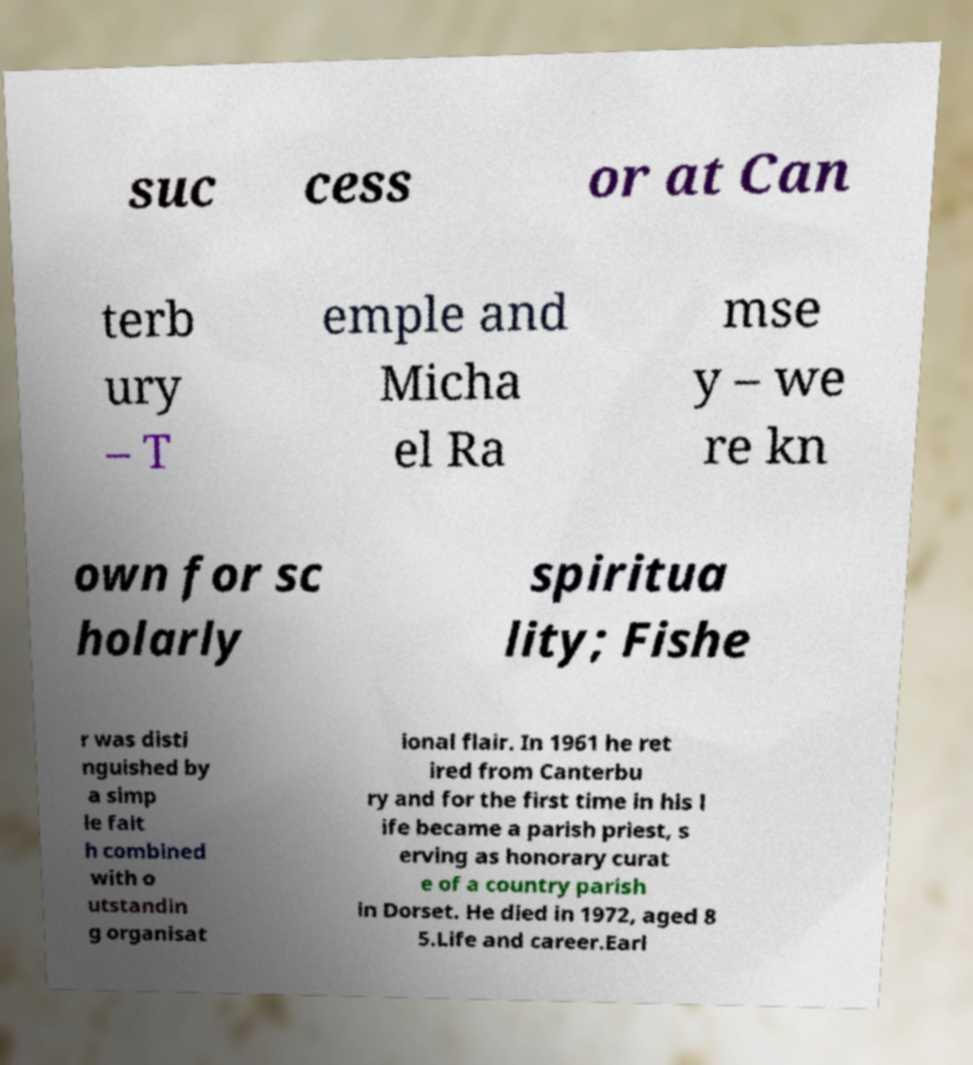Can you accurately transcribe the text from the provided image for me? suc cess or at Can terb ury – T emple and Micha el Ra mse y – we re kn own for sc holarly spiritua lity; Fishe r was disti nguished by a simp le fait h combined with o utstandin g organisat ional flair. In 1961 he ret ired from Canterbu ry and for the first time in his l ife became a parish priest, s erving as honorary curat e of a country parish in Dorset. He died in 1972, aged 8 5.Life and career.Earl 